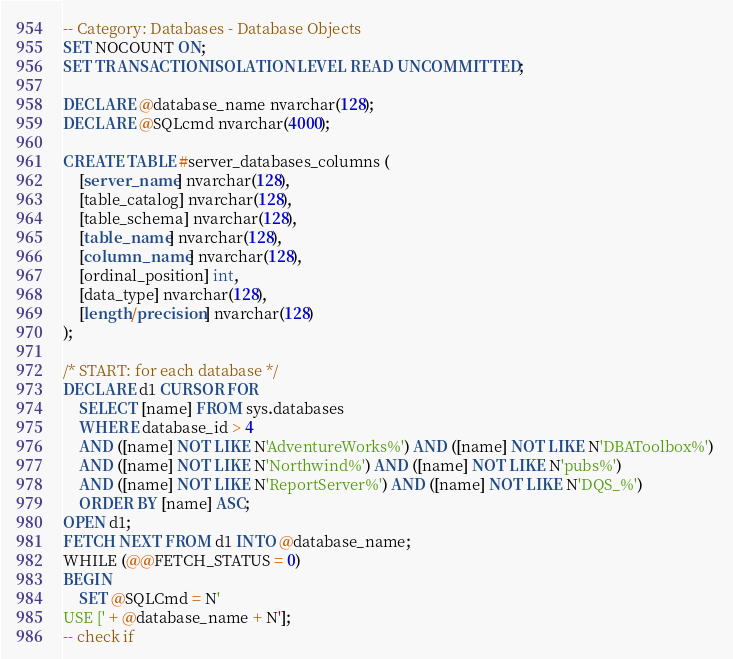<code> <loc_0><loc_0><loc_500><loc_500><_SQL_>-- Category: Databases - Database Objects
SET NOCOUNT ON;
SET TRANSACTION ISOLATION LEVEL READ UNCOMMITTED;

DECLARE @database_name nvarchar(128);
DECLARE @SQLcmd nvarchar(4000);

CREATE TABLE #server_databases_columns (
    [server_name] nvarchar(128),
    [table_catalog] nvarchar(128), 
    [table_schema] nvarchar(128), 
    [table_name] nvarchar(128), 
    [column_name] nvarchar(128), 
    [ordinal_position] int,
    [data_type] nvarchar(128), 
    [length/precision] nvarchar(128)
);

/* START: for each database */
DECLARE d1 CURSOR FOR
    SELECT [name] FROM sys.databases 
    WHERE database_id > 4
    AND ([name] NOT LIKE N'AdventureWorks%') AND ([name] NOT LIKE N'DBAToolbox%') 
    AND ([name] NOT LIKE N'Northwind%') AND ([name] NOT LIKE N'pubs%') 
    AND ([name] NOT LIKE N'ReportServer%') AND ([name] NOT LIKE N'DQS_%')
    ORDER BY [name] ASC;
OPEN d1;
FETCH NEXT FROM d1 INTO @database_name;
WHILE (@@FETCH_STATUS = 0)
BEGIN
    SET @SQLCmd = N'
USE [' + @database_name + N'];
-- check if </code> 